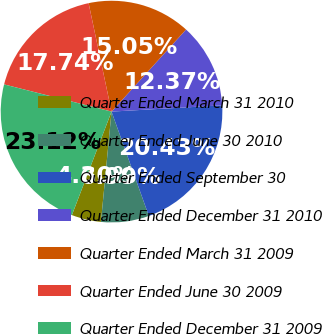<chart> <loc_0><loc_0><loc_500><loc_500><pie_chart><fcel>Quarter Ended March 31 2010<fcel>Quarter Ended June 30 2010<fcel>Quarter Ended September 30<fcel>Quarter Ended December 31 2010<fcel>Quarter Ended March 31 2009<fcel>Quarter Ended June 30 2009<fcel>Quarter Ended December 31 2009<nl><fcel>4.3%<fcel>6.99%<fcel>20.43%<fcel>12.37%<fcel>15.05%<fcel>17.74%<fcel>23.12%<nl></chart> 